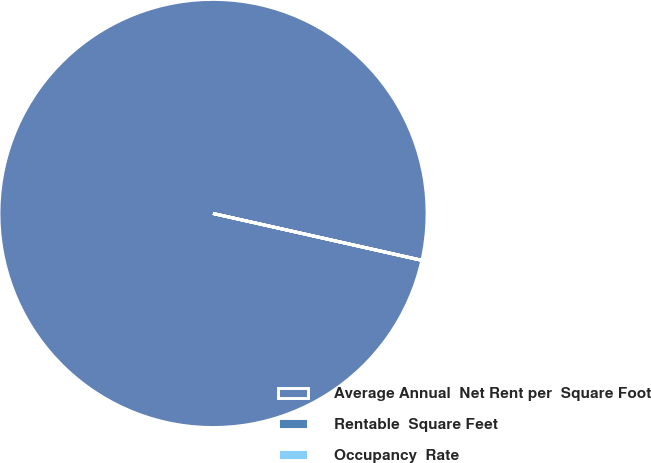<chart> <loc_0><loc_0><loc_500><loc_500><pie_chart><fcel>Average Annual  Net Rent per  Square Foot<fcel>Rentable  Square Feet<fcel>Occupancy  Rate<nl><fcel>99.98%<fcel>0.01%<fcel>0.01%<nl></chart> 